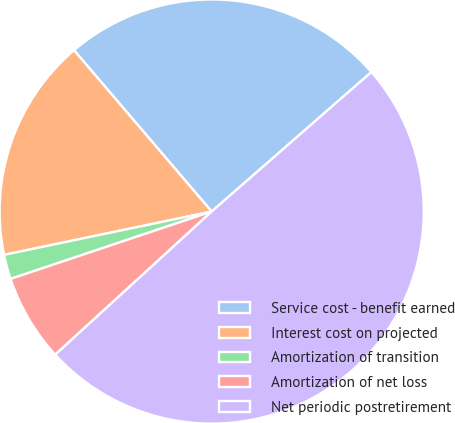Convert chart. <chart><loc_0><loc_0><loc_500><loc_500><pie_chart><fcel>Service cost - benefit earned<fcel>Interest cost on projected<fcel>Amortization of transition<fcel>Amortization of net loss<fcel>Net periodic postretirement<nl><fcel>24.82%<fcel>17.03%<fcel>1.87%<fcel>6.65%<fcel>49.63%<nl></chart> 